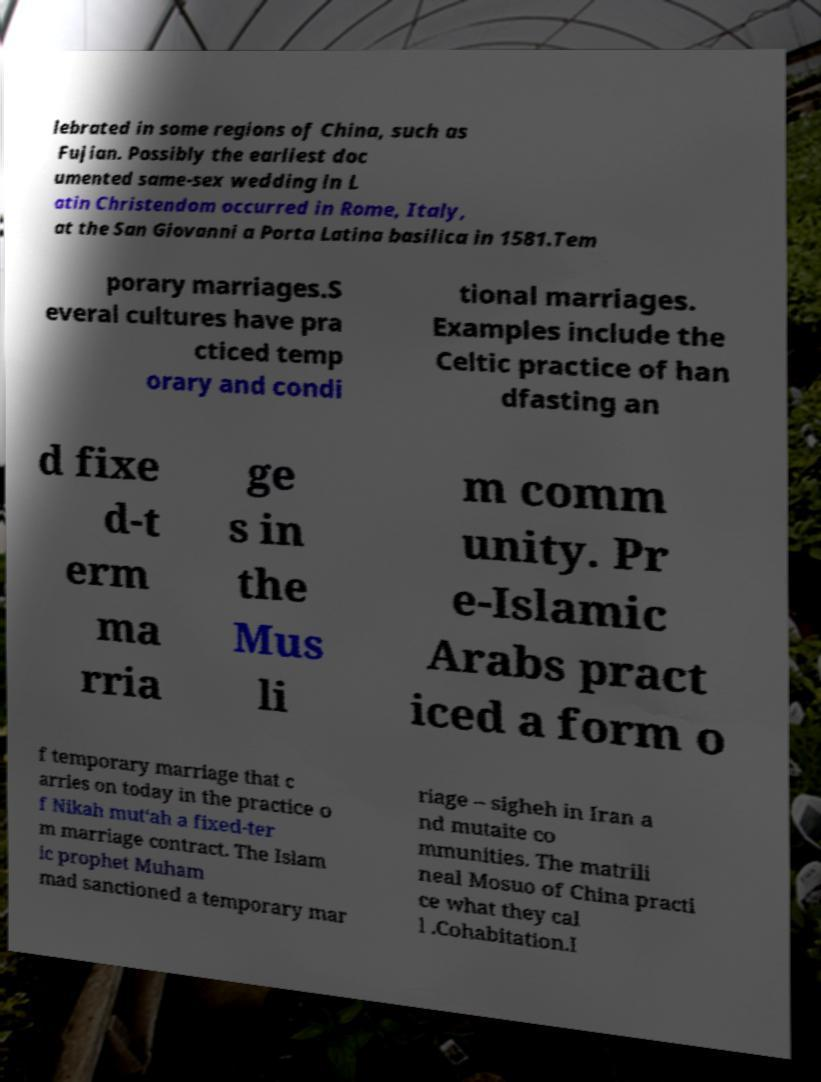Please read and relay the text visible in this image. What does it say? lebrated in some regions of China, such as Fujian. Possibly the earliest doc umented same-sex wedding in L atin Christendom occurred in Rome, Italy, at the San Giovanni a Porta Latina basilica in 1581.Tem porary marriages.S everal cultures have pra cticed temp orary and condi tional marriages. Examples include the Celtic practice of han dfasting an d fixe d-t erm ma rria ge s in the Mus li m comm unity. Pr e-Islamic Arabs pract iced a form o f temporary marriage that c arries on today in the practice o f Nikah mut‘ah a fixed-ter m marriage contract. The Islam ic prophet Muham mad sanctioned a temporary mar riage – sigheh in Iran a nd mutaite co mmunities. The matrili neal Mosuo of China practi ce what they cal l .Cohabitation.I 